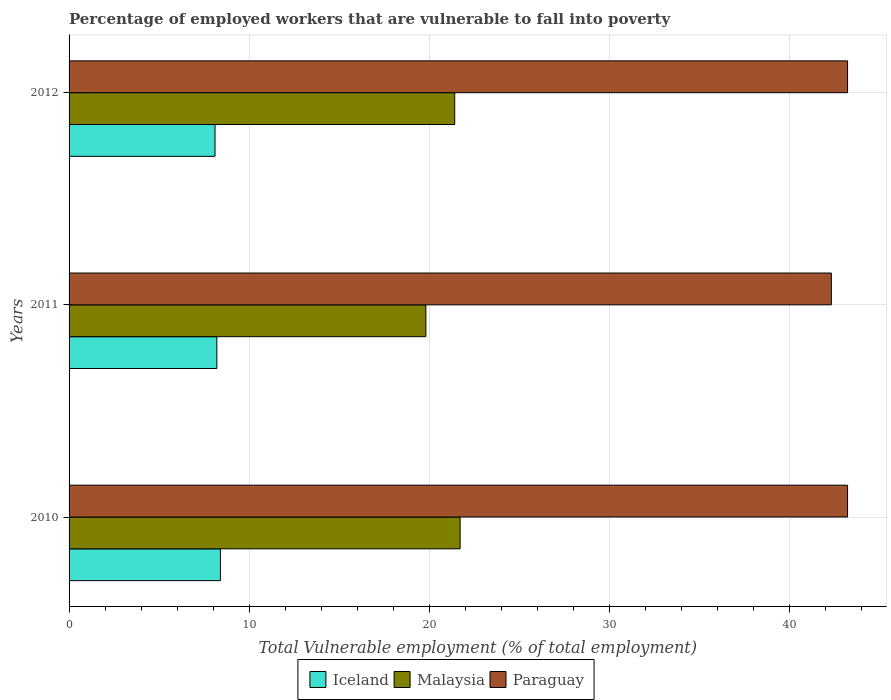How many different coloured bars are there?
Provide a short and direct response. 3. In how many cases, is the number of bars for a given year not equal to the number of legend labels?
Your answer should be compact. 0. What is the percentage of employed workers who are vulnerable to fall into poverty in Iceland in 2010?
Provide a succinct answer. 8.4. Across all years, what is the maximum percentage of employed workers who are vulnerable to fall into poverty in Malaysia?
Offer a terse response. 21.7. Across all years, what is the minimum percentage of employed workers who are vulnerable to fall into poverty in Iceland?
Ensure brevity in your answer.  8.1. In which year was the percentage of employed workers who are vulnerable to fall into poverty in Paraguay minimum?
Keep it short and to the point. 2011. What is the total percentage of employed workers who are vulnerable to fall into poverty in Iceland in the graph?
Your response must be concise. 24.7. What is the difference between the percentage of employed workers who are vulnerable to fall into poverty in Paraguay in 2010 and that in 2012?
Keep it short and to the point. 0. What is the difference between the percentage of employed workers who are vulnerable to fall into poverty in Iceland in 2011 and the percentage of employed workers who are vulnerable to fall into poverty in Malaysia in 2012?
Give a very brief answer. -13.2. What is the average percentage of employed workers who are vulnerable to fall into poverty in Iceland per year?
Offer a very short reply. 8.23. In the year 2012, what is the difference between the percentage of employed workers who are vulnerable to fall into poverty in Malaysia and percentage of employed workers who are vulnerable to fall into poverty in Iceland?
Your answer should be compact. 13.3. In how many years, is the percentage of employed workers who are vulnerable to fall into poverty in Malaysia greater than 14 %?
Keep it short and to the point. 3. What is the ratio of the percentage of employed workers who are vulnerable to fall into poverty in Malaysia in 2010 to that in 2011?
Your answer should be compact. 1.1. Is the percentage of employed workers who are vulnerable to fall into poverty in Iceland in 2010 less than that in 2012?
Make the answer very short. No. What is the difference between the highest and the second highest percentage of employed workers who are vulnerable to fall into poverty in Malaysia?
Make the answer very short. 0.3. What is the difference between the highest and the lowest percentage of employed workers who are vulnerable to fall into poverty in Iceland?
Your response must be concise. 0.3. In how many years, is the percentage of employed workers who are vulnerable to fall into poverty in Iceland greater than the average percentage of employed workers who are vulnerable to fall into poverty in Iceland taken over all years?
Your answer should be compact. 1. Is the sum of the percentage of employed workers who are vulnerable to fall into poverty in Paraguay in 2010 and 2011 greater than the maximum percentage of employed workers who are vulnerable to fall into poverty in Malaysia across all years?
Ensure brevity in your answer.  Yes. What does the 3rd bar from the top in 2010 represents?
Make the answer very short. Iceland. What does the 1st bar from the bottom in 2010 represents?
Make the answer very short. Iceland. Is it the case that in every year, the sum of the percentage of employed workers who are vulnerable to fall into poverty in Malaysia and percentage of employed workers who are vulnerable to fall into poverty in Paraguay is greater than the percentage of employed workers who are vulnerable to fall into poverty in Iceland?
Provide a succinct answer. Yes. How many bars are there?
Offer a terse response. 9. How many years are there in the graph?
Your response must be concise. 3. What is the difference between two consecutive major ticks on the X-axis?
Offer a terse response. 10. Are the values on the major ticks of X-axis written in scientific E-notation?
Keep it short and to the point. No. Where does the legend appear in the graph?
Your answer should be compact. Bottom center. How many legend labels are there?
Give a very brief answer. 3. What is the title of the graph?
Your response must be concise. Percentage of employed workers that are vulnerable to fall into poverty. What is the label or title of the X-axis?
Provide a succinct answer. Total Vulnerable employment (% of total employment). What is the label or title of the Y-axis?
Offer a terse response. Years. What is the Total Vulnerable employment (% of total employment) in Iceland in 2010?
Your answer should be compact. 8.4. What is the Total Vulnerable employment (% of total employment) in Malaysia in 2010?
Give a very brief answer. 21.7. What is the Total Vulnerable employment (% of total employment) in Paraguay in 2010?
Provide a short and direct response. 43.2. What is the Total Vulnerable employment (% of total employment) in Iceland in 2011?
Your answer should be very brief. 8.2. What is the Total Vulnerable employment (% of total employment) in Malaysia in 2011?
Keep it short and to the point. 19.8. What is the Total Vulnerable employment (% of total employment) in Paraguay in 2011?
Your answer should be very brief. 42.3. What is the Total Vulnerable employment (% of total employment) of Iceland in 2012?
Give a very brief answer. 8.1. What is the Total Vulnerable employment (% of total employment) in Malaysia in 2012?
Ensure brevity in your answer.  21.4. What is the Total Vulnerable employment (% of total employment) of Paraguay in 2012?
Make the answer very short. 43.2. Across all years, what is the maximum Total Vulnerable employment (% of total employment) in Iceland?
Offer a very short reply. 8.4. Across all years, what is the maximum Total Vulnerable employment (% of total employment) in Malaysia?
Your response must be concise. 21.7. Across all years, what is the maximum Total Vulnerable employment (% of total employment) of Paraguay?
Your answer should be very brief. 43.2. Across all years, what is the minimum Total Vulnerable employment (% of total employment) in Iceland?
Ensure brevity in your answer.  8.1. Across all years, what is the minimum Total Vulnerable employment (% of total employment) in Malaysia?
Give a very brief answer. 19.8. Across all years, what is the minimum Total Vulnerable employment (% of total employment) in Paraguay?
Your answer should be very brief. 42.3. What is the total Total Vulnerable employment (% of total employment) in Iceland in the graph?
Your response must be concise. 24.7. What is the total Total Vulnerable employment (% of total employment) of Malaysia in the graph?
Provide a short and direct response. 62.9. What is the total Total Vulnerable employment (% of total employment) in Paraguay in the graph?
Your answer should be compact. 128.7. What is the difference between the Total Vulnerable employment (% of total employment) in Malaysia in 2010 and that in 2011?
Give a very brief answer. 1.9. What is the difference between the Total Vulnerable employment (% of total employment) in Iceland in 2011 and that in 2012?
Ensure brevity in your answer.  0.1. What is the difference between the Total Vulnerable employment (% of total employment) of Malaysia in 2011 and that in 2012?
Keep it short and to the point. -1.6. What is the difference between the Total Vulnerable employment (% of total employment) in Iceland in 2010 and the Total Vulnerable employment (% of total employment) in Paraguay in 2011?
Give a very brief answer. -33.9. What is the difference between the Total Vulnerable employment (% of total employment) in Malaysia in 2010 and the Total Vulnerable employment (% of total employment) in Paraguay in 2011?
Provide a succinct answer. -20.6. What is the difference between the Total Vulnerable employment (% of total employment) in Iceland in 2010 and the Total Vulnerable employment (% of total employment) in Paraguay in 2012?
Give a very brief answer. -34.8. What is the difference between the Total Vulnerable employment (% of total employment) of Malaysia in 2010 and the Total Vulnerable employment (% of total employment) of Paraguay in 2012?
Your answer should be compact. -21.5. What is the difference between the Total Vulnerable employment (% of total employment) of Iceland in 2011 and the Total Vulnerable employment (% of total employment) of Paraguay in 2012?
Keep it short and to the point. -35. What is the difference between the Total Vulnerable employment (% of total employment) of Malaysia in 2011 and the Total Vulnerable employment (% of total employment) of Paraguay in 2012?
Give a very brief answer. -23.4. What is the average Total Vulnerable employment (% of total employment) in Iceland per year?
Provide a short and direct response. 8.23. What is the average Total Vulnerable employment (% of total employment) in Malaysia per year?
Keep it short and to the point. 20.97. What is the average Total Vulnerable employment (% of total employment) in Paraguay per year?
Offer a terse response. 42.9. In the year 2010, what is the difference between the Total Vulnerable employment (% of total employment) in Iceland and Total Vulnerable employment (% of total employment) in Paraguay?
Keep it short and to the point. -34.8. In the year 2010, what is the difference between the Total Vulnerable employment (% of total employment) in Malaysia and Total Vulnerable employment (% of total employment) in Paraguay?
Your answer should be compact. -21.5. In the year 2011, what is the difference between the Total Vulnerable employment (% of total employment) in Iceland and Total Vulnerable employment (% of total employment) in Paraguay?
Ensure brevity in your answer.  -34.1. In the year 2011, what is the difference between the Total Vulnerable employment (% of total employment) of Malaysia and Total Vulnerable employment (% of total employment) of Paraguay?
Keep it short and to the point. -22.5. In the year 2012, what is the difference between the Total Vulnerable employment (% of total employment) of Iceland and Total Vulnerable employment (% of total employment) of Paraguay?
Give a very brief answer. -35.1. In the year 2012, what is the difference between the Total Vulnerable employment (% of total employment) in Malaysia and Total Vulnerable employment (% of total employment) in Paraguay?
Offer a very short reply. -21.8. What is the ratio of the Total Vulnerable employment (% of total employment) of Iceland in 2010 to that in 2011?
Your answer should be very brief. 1.02. What is the ratio of the Total Vulnerable employment (% of total employment) of Malaysia in 2010 to that in 2011?
Your answer should be compact. 1.1. What is the ratio of the Total Vulnerable employment (% of total employment) of Paraguay in 2010 to that in 2011?
Give a very brief answer. 1.02. What is the ratio of the Total Vulnerable employment (% of total employment) in Malaysia in 2010 to that in 2012?
Give a very brief answer. 1.01. What is the ratio of the Total Vulnerable employment (% of total employment) in Paraguay in 2010 to that in 2012?
Ensure brevity in your answer.  1. What is the ratio of the Total Vulnerable employment (% of total employment) of Iceland in 2011 to that in 2012?
Offer a very short reply. 1.01. What is the ratio of the Total Vulnerable employment (% of total employment) of Malaysia in 2011 to that in 2012?
Ensure brevity in your answer.  0.93. What is the ratio of the Total Vulnerable employment (% of total employment) of Paraguay in 2011 to that in 2012?
Offer a terse response. 0.98. What is the difference between the highest and the lowest Total Vulnerable employment (% of total employment) of Iceland?
Give a very brief answer. 0.3. What is the difference between the highest and the lowest Total Vulnerable employment (% of total employment) in Paraguay?
Provide a short and direct response. 0.9. 